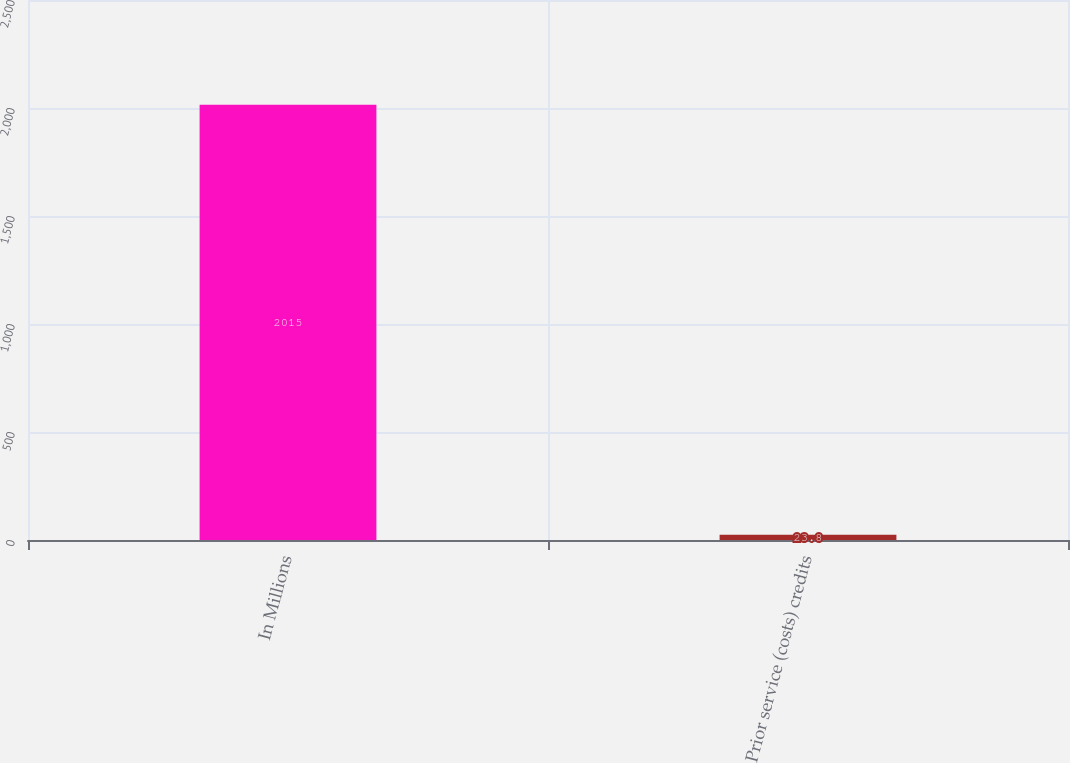Convert chart. <chart><loc_0><loc_0><loc_500><loc_500><bar_chart><fcel>In Millions<fcel>Prior service (costs) credits<nl><fcel>2015<fcel>23.8<nl></chart> 